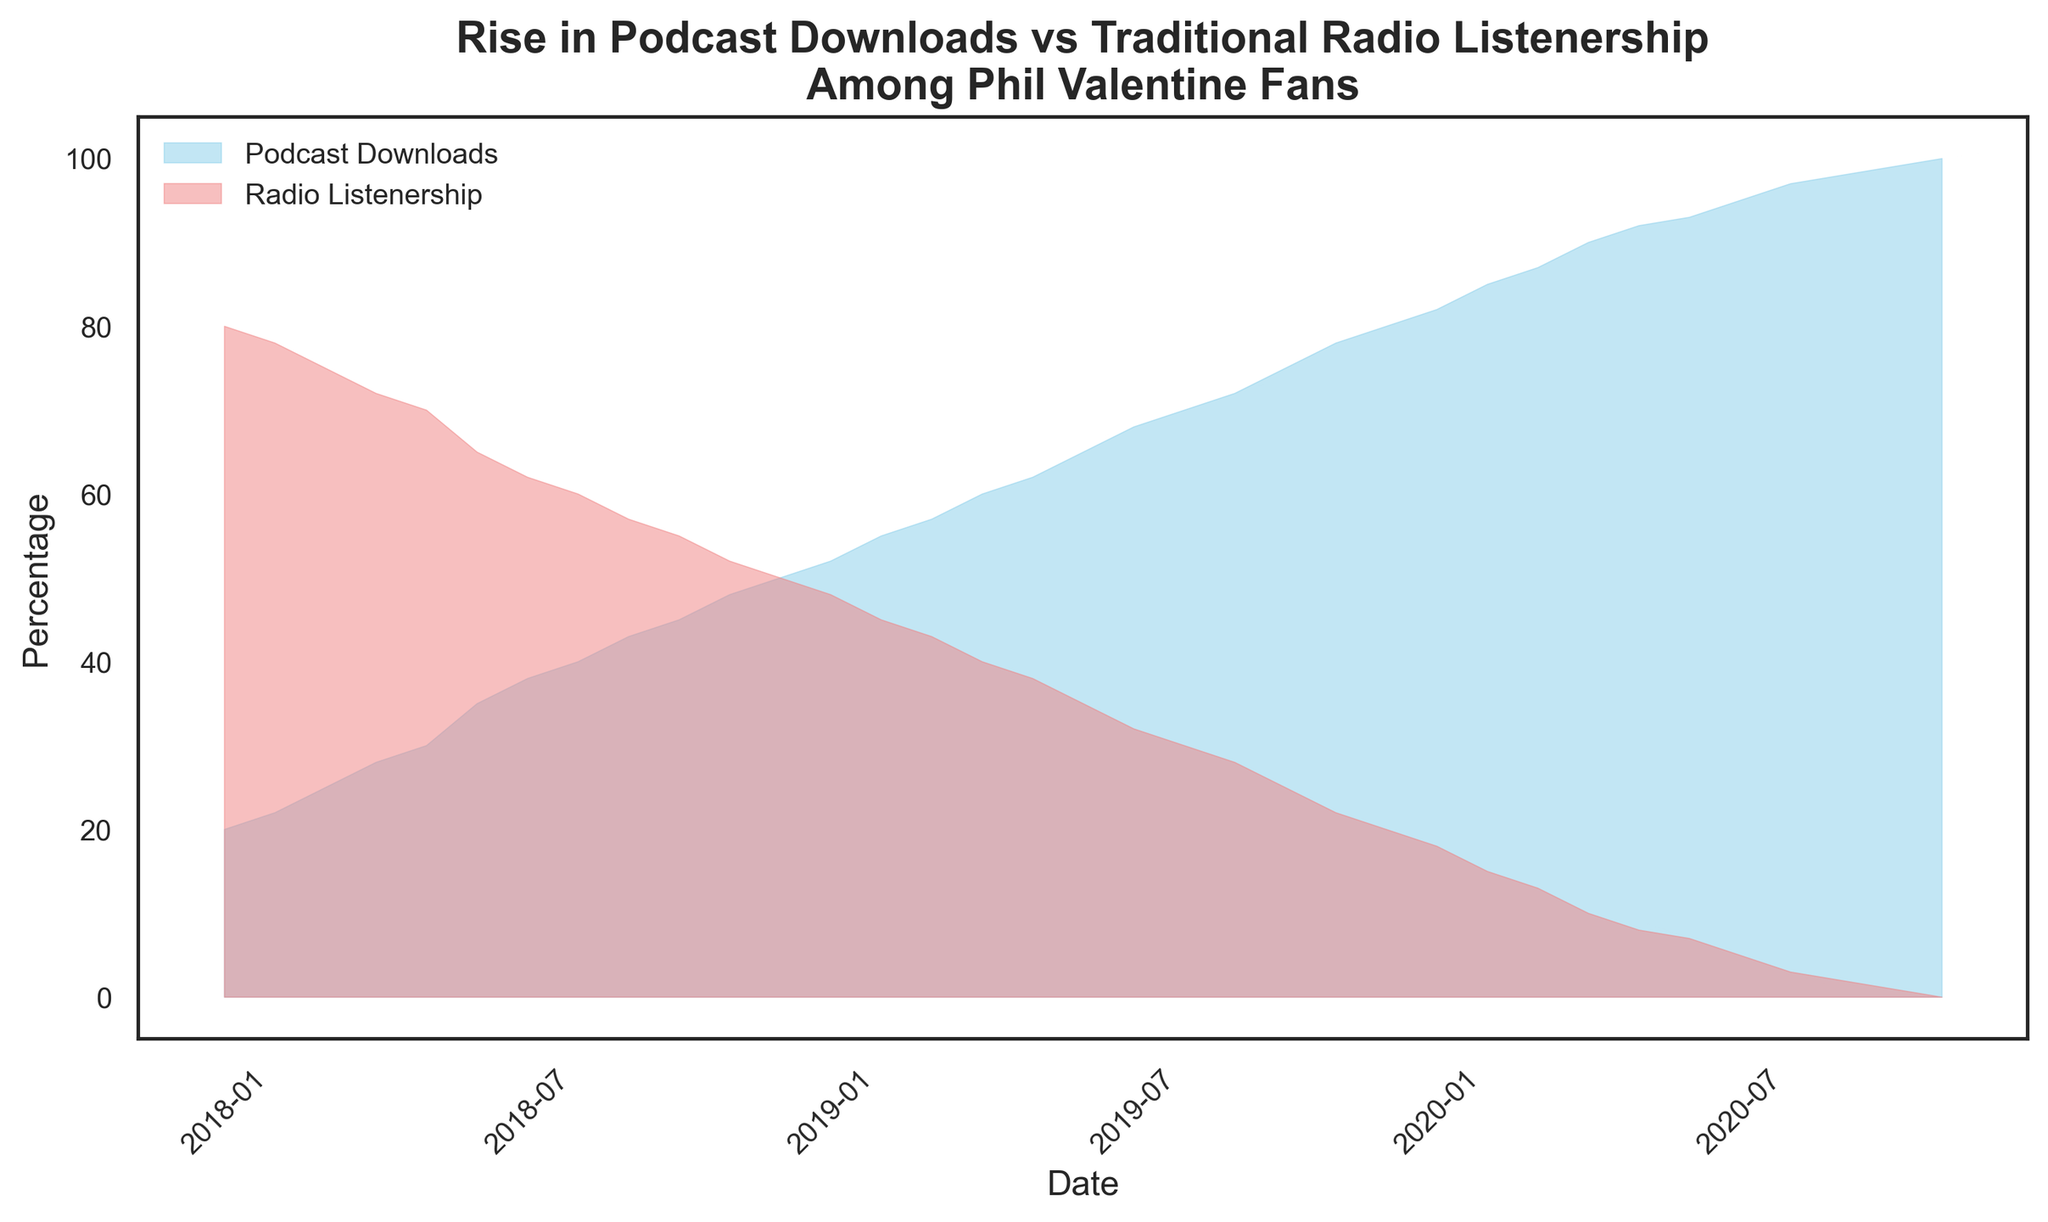What is the percentage of podcast downloads in January 2018? In January 2018, the percentage of podcast downloads is indicated by the height of the sky-blue area above the x-axis at the first date mark. It is labeled as 20% in the data provided.
Answer: 20% What visual trends are noticeable in the podcast downloads and radio listenership from the start until November 2020? The sky-blue area representing podcast downloads rises steadily from 20% to 100%, while the light coral area representing radio listenership declines consistently from 80% to 0%, showing a clear trend of increasing podcast downloads and decreasing radio listenership.
Answer: Increasing podcast downloads, decreasing radio listenership How do the podcast downloads in December 2018 compare to those in December 2019? To compare, examine the height of the sky-blue area in both December 2018 and December 2019. In December 2018, podcast downloads are at 50%; in December 2019, they rise to 80%. The increase is 30%.
Answer: Increased by 30 percentage points What is the difference between the percentages of podcast downloads and radio listenership in March 2019? The percentage of podcast downloads in March 2019 is 57%, and radio listenership is 43%. The difference is calculated by subtracting 43 from 57.
Answer: 14% In which month did podcast downloads surpass 50%? Review the chart for the point where the sky-blue area exceeds 50%. This occurs in December 2018.
Answer: December 2018 What change in the percentage of radio listenership is observed between June 2018 and June 2020? In June 2018, the percentage of radio listenership is 65%. By June 2020, it drops to 7%. The change is the difference between these values: 65 - 7 = 58.
Answer: Decreased by 58 percentage points When did podcast downloads reach parity with traditional radio listenership? Parity occurs when both download and listenership percentages are equal. This is observed in December 2018, where both are 50%.
Answer: December 2018 Which month shows the steepest increase in podcast downloads? The steepest increase is identified by the largest vertical gap between two consecutive data points in the sky-blue area. This occurs between October 2019 (75%) and November 2019 (78%), which is a 3% increase. This is merely an example; the increase could be larger at other points if examined closely.
Answer: Near the end of 2019 (November to December) What percentage of Phil Valentine fans still prefer traditional radio in July 2019? The light coral area representing radio listenership in July 2019 is at 32%.
Answer: 32% How does the total change in percentage points for podcast downloads from January 2018 to November 2020 compare to that of traditional radio listenership? The initial podcast download percentage in January 2018 is 20%, rising to 100% by November 2020, a total change of 80 percentage points. Radio listenership starts at 80% and drops to 0%, also a total change of 80 percentage points.
Answer: Both changed by 80 percentage points 